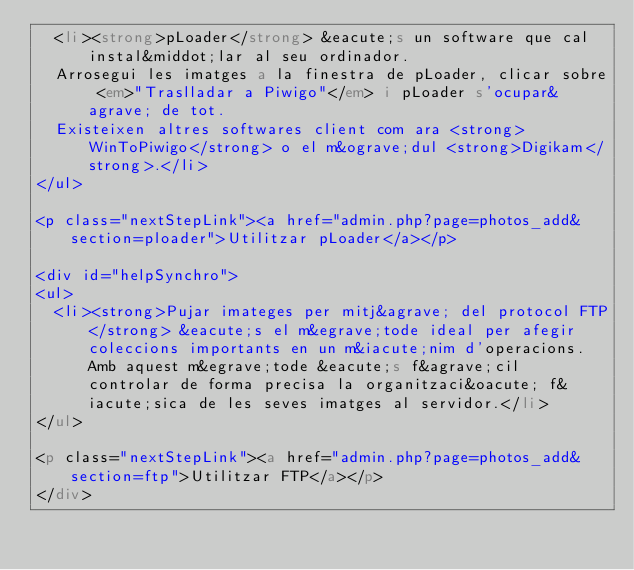<code> <loc_0><loc_0><loc_500><loc_500><_HTML_>  <li><strong>pLoader</strong> &eacute;s un software que cal instal&middot;lar al seu ordinador.
  Arrosegui les imatges a la finestra de pLoader, clicar sobre <em>"Traslladar a Piwigo"</em> i pLoader s'ocupar&agrave; de tot.
  Existeixen altres softwares client com ara <strong>WinToPiwigo</strong> o el m&ograve;dul <strong>Digikam</strong>.</li>
</ul>

<p class="nextStepLink"><a href="admin.php?page=photos_add&section=ploader">Utilitzar pLoader</a></p>

<div id="helpSynchro">
<ul>
  <li><strong>Pujar imateges per mitj&agrave; del protocol FTP</strong> &eacute;s el m&egrave;tode ideal per afegir coleccions importants en un m&iacute;nim d'operacions. Amb aquest m&egrave;tode &eacute;s f&agrave;cil controlar de forma precisa la organitzaci&oacute; f&iacute;sica de les seves imatges al servidor.</li>
</ul>

<p class="nextStepLink"><a href="admin.php?page=photos_add&section=ftp">Utilitzar FTP</a></p>
</div></code> 